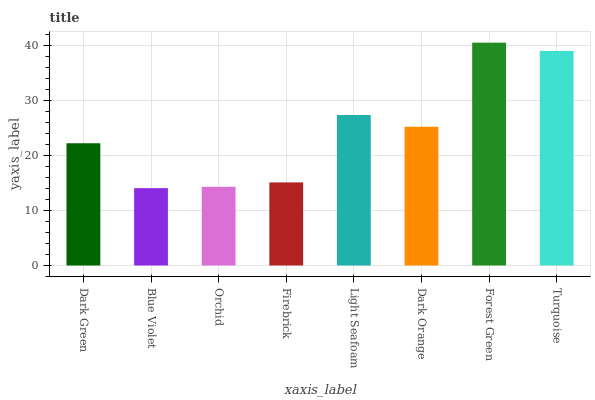Is Orchid the minimum?
Answer yes or no. No. Is Orchid the maximum?
Answer yes or no. No. Is Orchid greater than Blue Violet?
Answer yes or no. Yes. Is Blue Violet less than Orchid?
Answer yes or no. Yes. Is Blue Violet greater than Orchid?
Answer yes or no. No. Is Orchid less than Blue Violet?
Answer yes or no. No. Is Dark Orange the high median?
Answer yes or no. Yes. Is Dark Green the low median?
Answer yes or no. Yes. Is Forest Green the high median?
Answer yes or no. No. Is Dark Orange the low median?
Answer yes or no. No. 